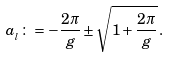<formula> <loc_0><loc_0><loc_500><loc_500>a _ { _ { l } } \colon = - \frac { 2 \pi } { g } \pm \sqrt { 1 + \frac { 2 \pi } { g } } \, .</formula> 